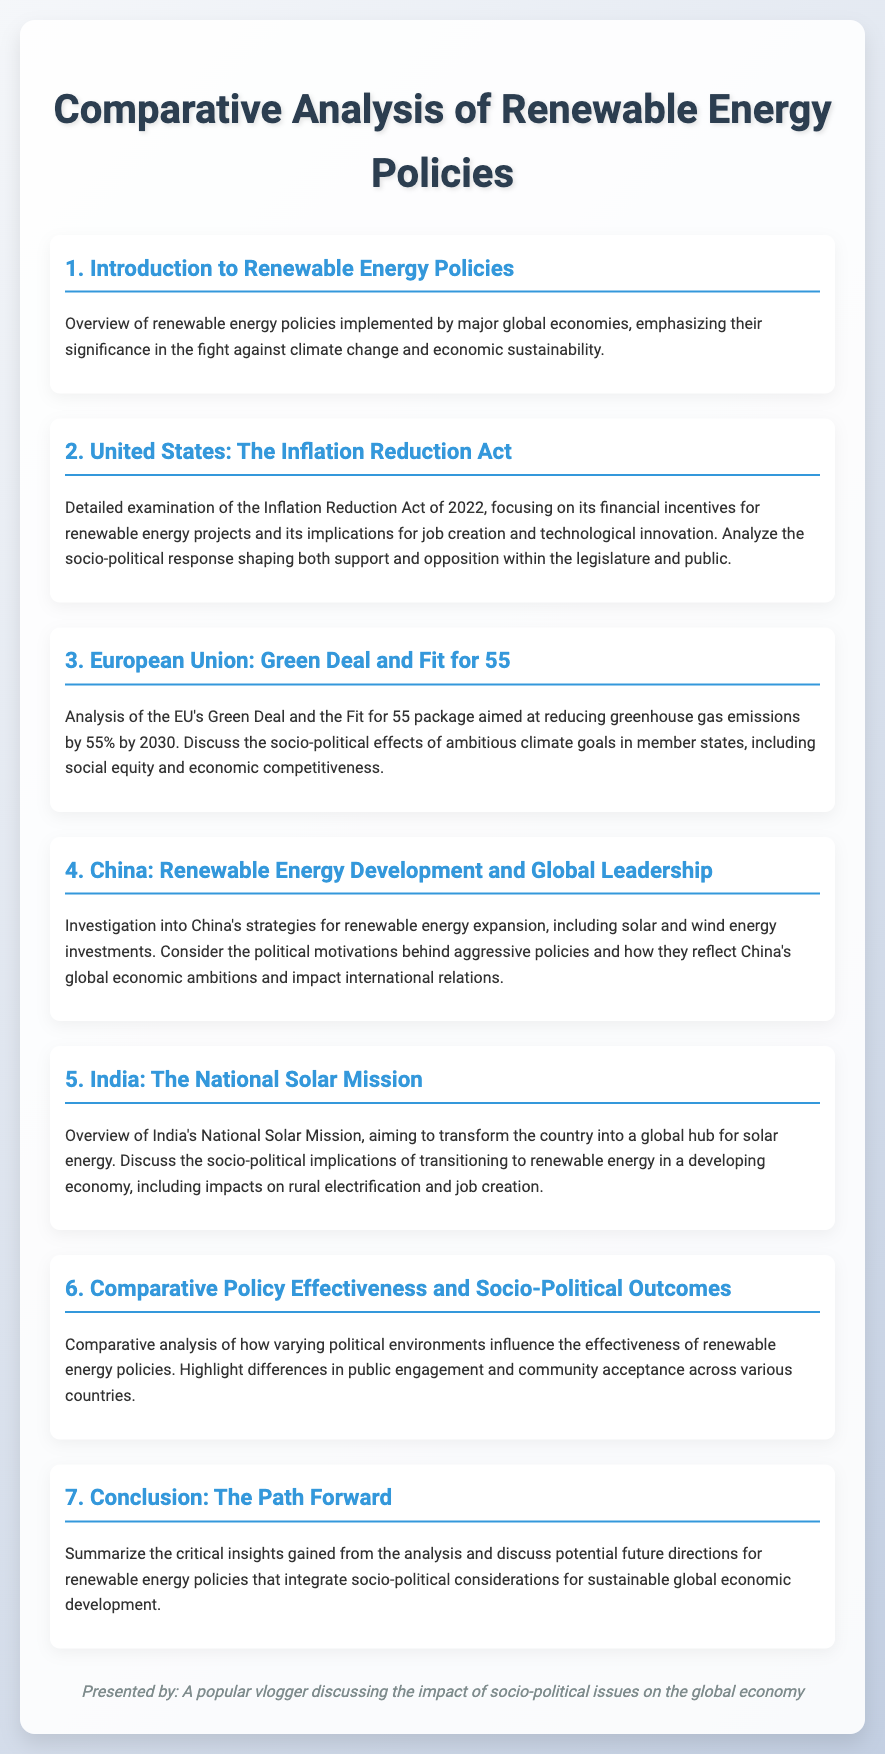what is the title of the document? The title of the document is presented at the top and reflects the main topic, which is a comparative analysis of renewable energy policies.
Answer: Comparative Analysis of Renewable Energy Policies who is the vlogger presenting the document? The presenter of the document is identified at the end, emphasizing their focus on socio-political issues and the global economy.
Answer: A popular vlogger discussing the impact of socio-political issues on the global economy what policy is analyzed for the United States? The specific policy discussed in the section about the United States is clearly stated and focuses on financial implications.
Answer: Inflation Reduction Act what is the EU's target for greenhouse gas emissions reduction? The EU's ambitious goal is mentioned in the context of the Green Deal and describes the percentage reduction aimed by 2030.
Answer: 55% which country’s National Solar Mission is discussed as transforming into a global hub? The document explicitly states the country associated with the National Solar Mission and its implications for solar energy.
Answer: India what is the main focus of section six? This section addresses the overall impact of political environments on the effectiveness of renewable energy policies globally.
Answer: Comparative analysis how does China view its renewable energy policies? The document highlights the broader economic ambitions linked to China's approach to renewable energy expansion.
Answer: Global economic ambitions what is the conclusion about future directions for renewable energy policies? The conclusion summarizes insights and suggests integrating socio-political considerations for sustainability.
Answer: Socio-political considerations for sustainable development 